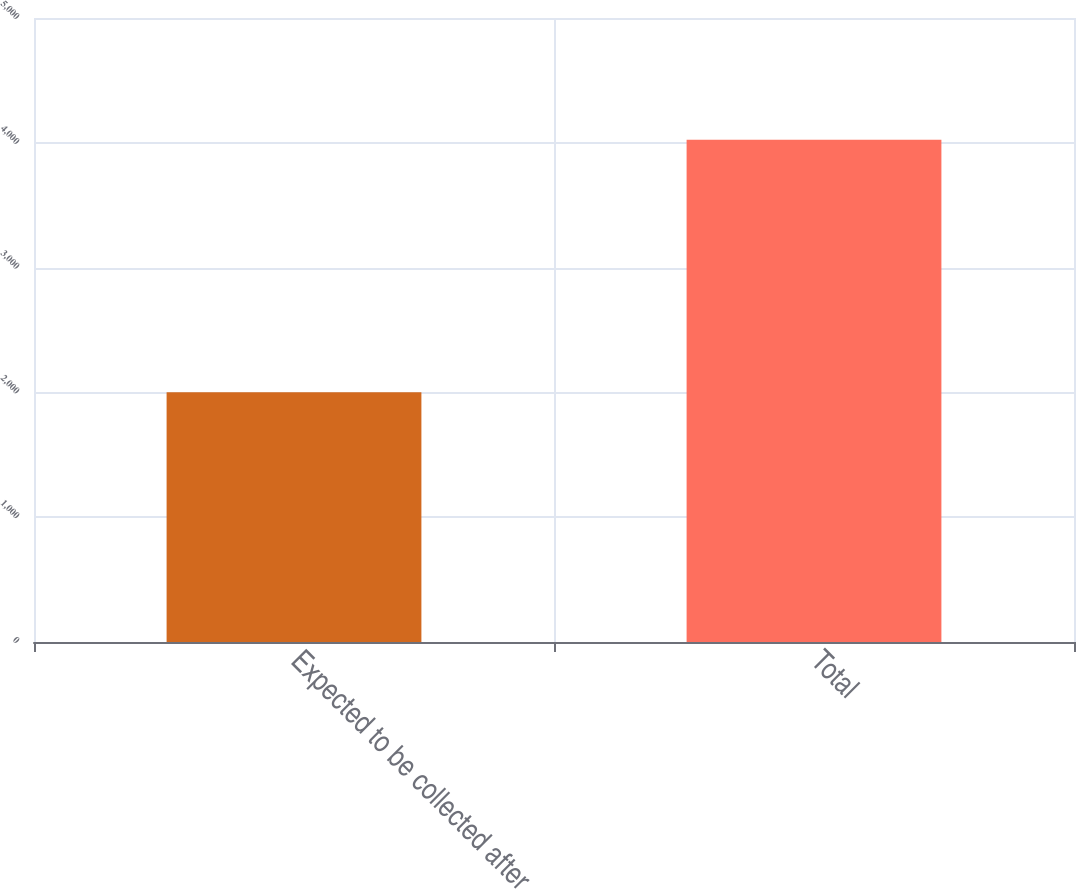Convert chart. <chart><loc_0><loc_0><loc_500><loc_500><bar_chart><fcel>Expected to be collected after<fcel>Total<nl><fcel>2001<fcel>4025<nl></chart> 